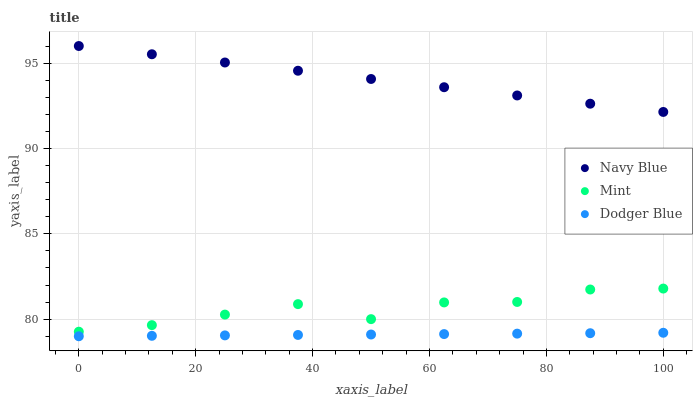Does Dodger Blue have the minimum area under the curve?
Answer yes or no. Yes. Does Navy Blue have the maximum area under the curve?
Answer yes or no. Yes. Does Mint have the minimum area under the curve?
Answer yes or no. No. Does Mint have the maximum area under the curve?
Answer yes or no. No. Is Dodger Blue the smoothest?
Answer yes or no. Yes. Is Mint the roughest?
Answer yes or no. Yes. Is Mint the smoothest?
Answer yes or no. No. Is Dodger Blue the roughest?
Answer yes or no. No. Does Dodger Blue have the lowest value?
Answer yes or no. Yes. Does Mint have the lowest value?
Answer yes or no. No. Does Navy Blue have the highest value?
Answer yes or no. Yes. Does Mint have the highest value?
Answer yes or no. No. Is Dodger Blue less than Mint?
Answer yes or no. Yes. Is Navy Blue greater than Mint?
Answer yes or no. Yes. Does Dodger Blue intersect Mint?
Answer yes or no. No. 